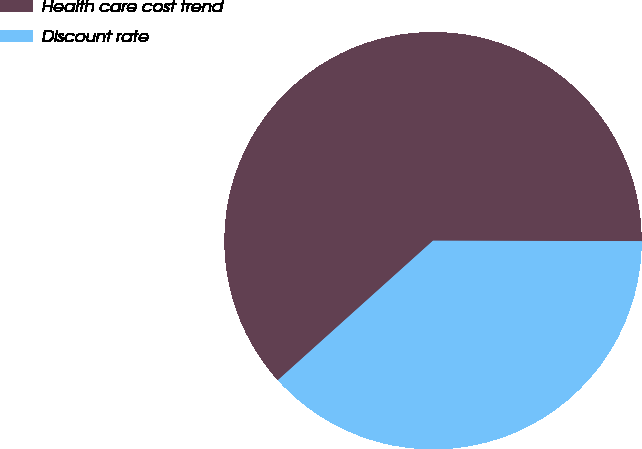<chart> <loc_0><loc_0><loc_500><loc_500><pie_chart><fcel>Health care cost trend<fcel>Discount rate<nl><fcel>61.69%<fcel>38.31%<nl></chart> 